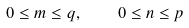<formula> <loc_0><loc_0><loc_500><loc_500>0 \leq m \leq q , \quad 0 \leq n \leq p</formula> 